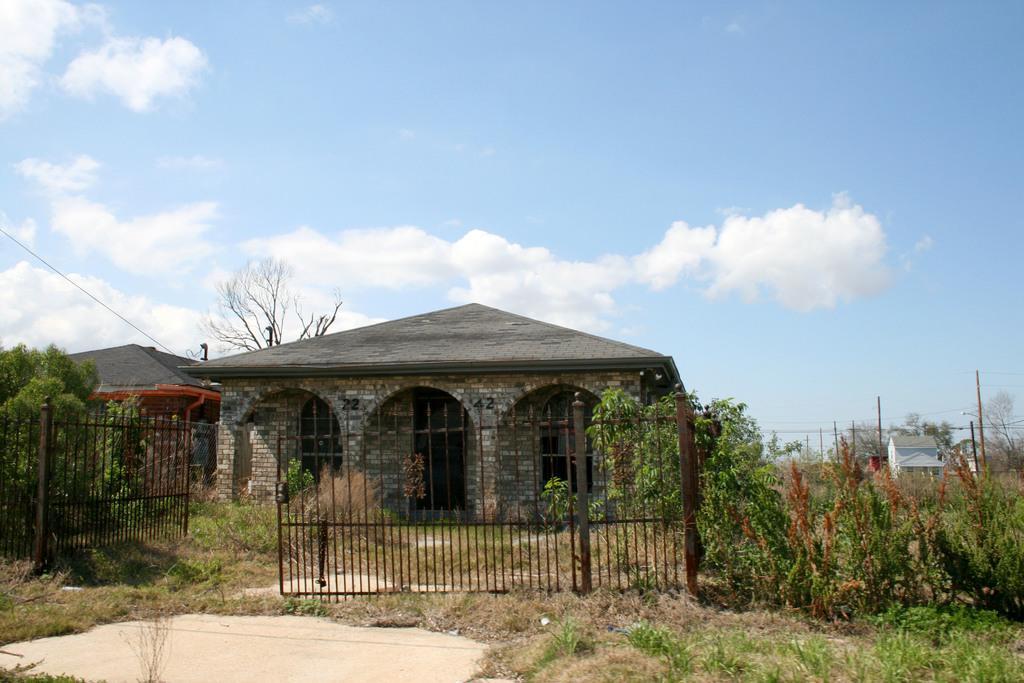Describe this image in one or two sentences. In this picture we can see grass, plants, gate, poles, houses, and trees. In the background there is sky with clouds. 